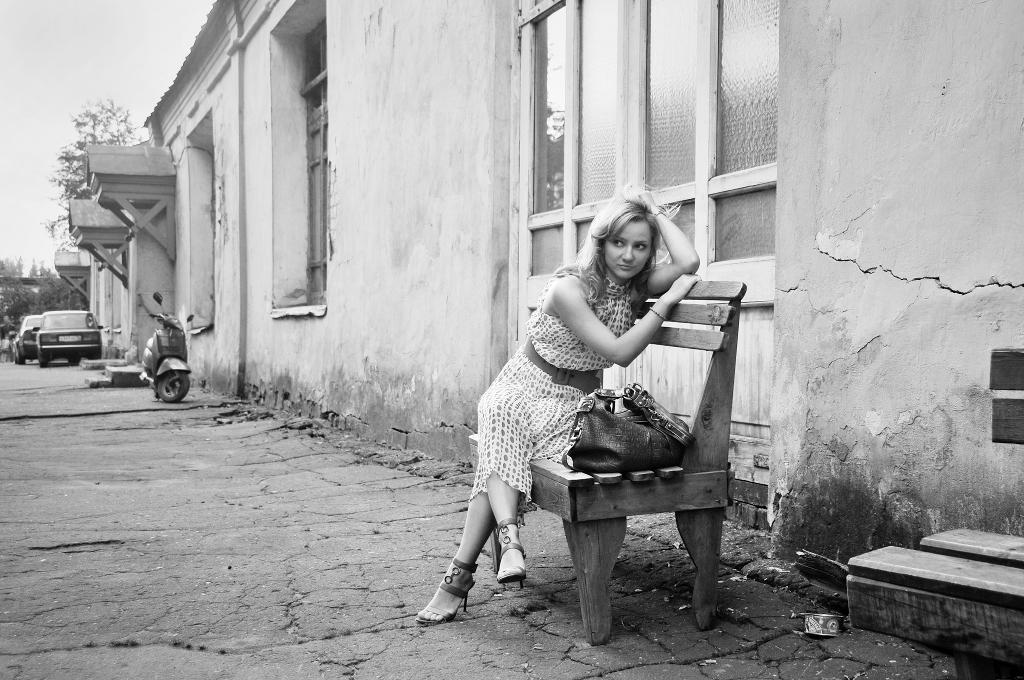How would you summarize this image in a sentence or two? In this image I see a woman who is sitting on the bench and there is a bag on it. In the background I see the building and windows and vehicles on the path. 